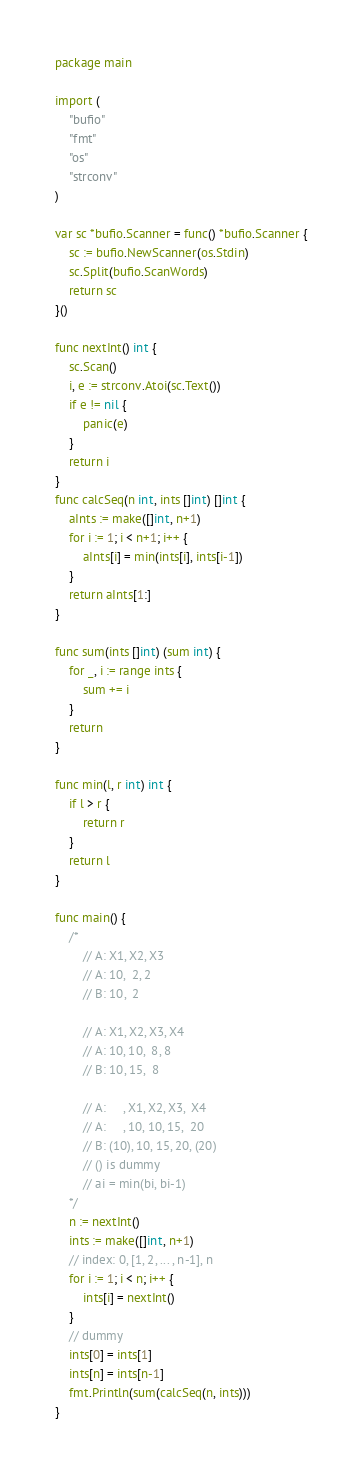Convert code to text. <code><loc_0><loc_0><loc_500><loc_500><_Go_>package main

import (
	"bufio"
	"fmt"
	"os"
	"strconv"
)

var sc *bufio.Scanner = func() *bufio.Scanner {
	sc := bufio.NewScanner(os.Stdin)
	sc.Split(bufio.ScanWords)
	return sc
}()

func nextInt() int {
	sc.Scan()
	i, e := strconv.Atoi(sc.Text())
	if e != nil {
		panic(e)
	}
	return i
}
func calcSeq(n int, ints []int) []int {
	aInts := make([]int, n+1)
	for i := 1; i < n+1; i++ {
		aInts[i] = min(ints[i], ints[i-1])
	}
	return aInts[1:]
}

func sum(ints []int) (sum int) {
	for _, i := range ints {
		sum += i
	}
	return
}

func min(l, r int) int {
	if l > r {
		return r
	}
	return l
}

func main() {
	/*
		// A: X1, X2, X3
		// A: 10,  2, 2
		// B: 10,  2

		// A: X1, X2, X3, X4
		// A: 10, 10,  8, 8
		// B: 10, 15,  8

		// A:     , X1, X2, X3,  X4
		// A:     , 10, 10, 15,  20
		// B: (10), 10, 15, 20, (20)
		// () is dummy
		// ai = min(bi, bi-1)
	*/
	n := nextInt()
	ints := make([]int, n+1)
	// index: 0, [1, 2, ... , n-1], n
	for i := 1; i < n; i++ {
		ints[i] = nextInt()
	}
	// dummy
	ints[0] = ints[1]
	ints[n] = ints[n-1]
	fmt.Println(sum(calcSeq(n, ints)))
}
</code> 